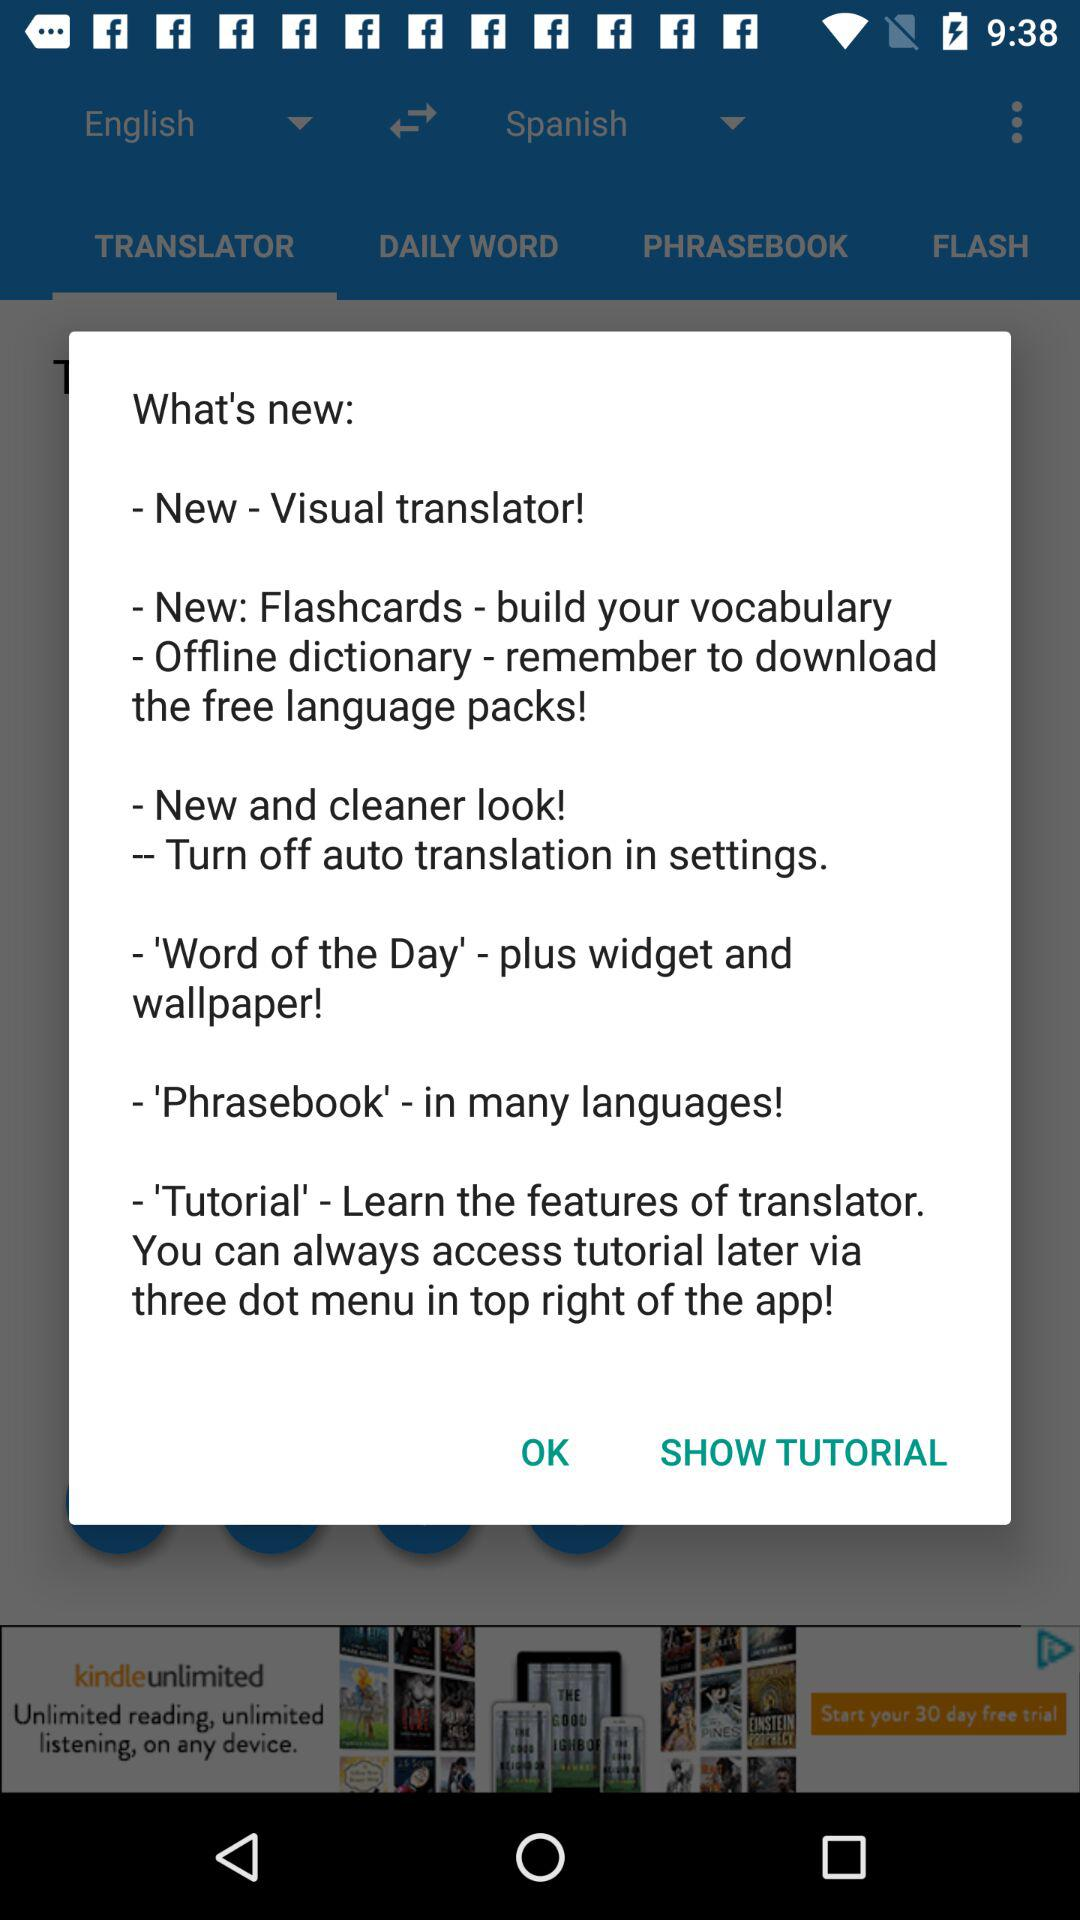Which tab is selected? The selected tab is "TRANSLATOR". 